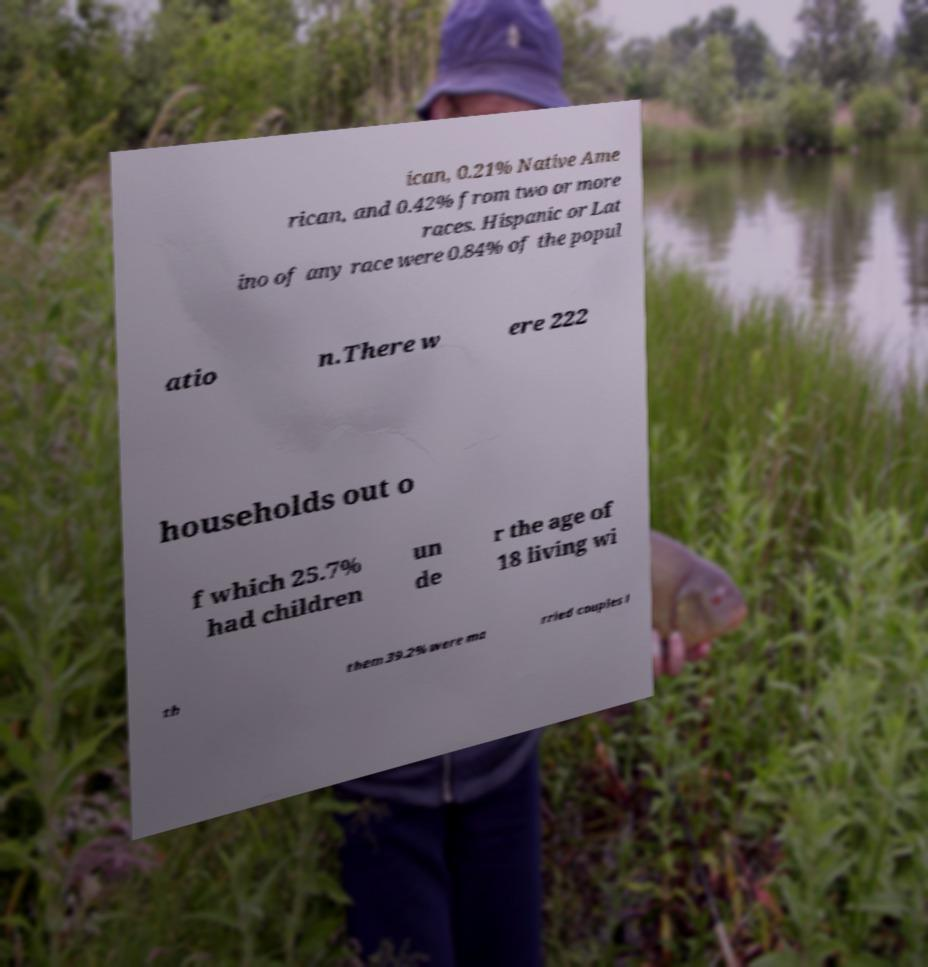There's text embedded in this image that I need extracted. Can you transcribe it verbatim? ican, 0.21% Native Ame rican, and 0.42% from two or more races. Hispanic or Lat ino of any race were 0.84% of the popul atio n.There w ere 222 households out o f which 25.7% had children un de r the age of 18 living wi th them 39.2% were ma rried couples l 